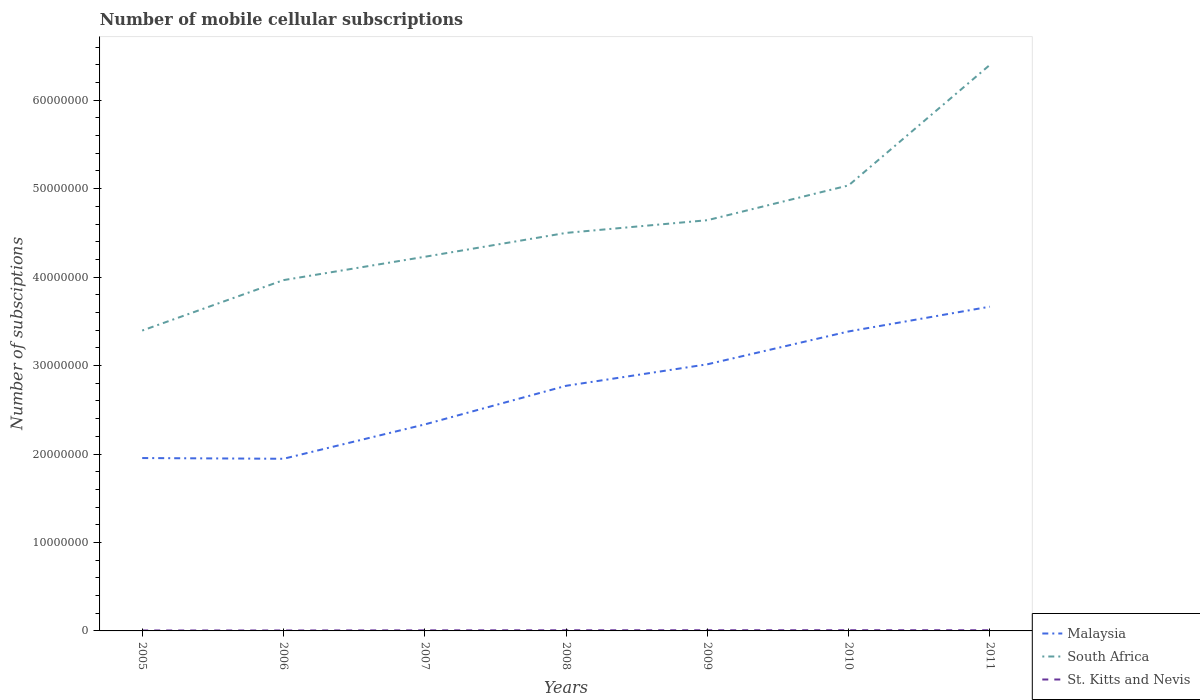Does the line corresponding to South Africa intersect with the line corresponding to St. Kitts and Nevis?
Offer a terse response. No. Is the number of lines equal to the number of legend labels?
Your response must be concise. Yes. Across all years, what is the maximum number of mobile cellular subscriptions in Malaysia?
Your answer should be very brief. 1.95e+07. What is the total number of mobile cellular subscriptions in Malaysia in the graph?
Give a very brief answer. -2.43e+06. What is the difference between the highest and the second highest number of mobile cellular subscriptions in Malaysia?
Your answer should be compact. 1.72e+07. How many lines are there?
Provide a short and direct response. 3. How many years are there in the graph?
Give a very brief answer. 7. Are the values on the major ticks of Y-axis written in scientific E-notation?
Offer a terse response. No. Does the graph contain any zero values?
Your answer should be very brief. No. Does the graph contain grids?
Make the answer very short. No. How many legend labels are there?
Your answer should be very brief. 3. How are the legend labels stacked?
Your answer should be very brief. Vertical. What is the title of the graph?
Give a very brief answer. Number of mobile cellular subscriptions. Does "Vietnam" appear as one of the legend labels in the graph?
Ensure brevity in your answer.  No. What is the label or title of the X-axis?
Offer a very short reply. Years. What is the label or title of the Y-axis?
Your response must be concise. Number of subsciptions. What is the Number of subsciptions in Malaysia in 2005?
Give a very brief answer. 1.95e+07. What is the Number of subsciptions of South Africa in 2005?
Make the answer very short. 3.40e+07. What is the Number of subsciptions in St. Kitts and Nevis in 2005?
Your answer should be compact. 5.10e+04. What is the Number of subsciptions in Malaysia in 2006?
Keep it short and to the point. 1.95e+07. What is the Number of subsciptions in South Africa in 2006?
Make the answer very short. 3.97e+07. What is the Number of subsciptions in St. Kitts and Nevis in 2006?
Your answer should be very brief. 5.10e+04. What is the Number of subsciptions in Malaysia in 2007?
Provide a succinct answer. 2.33e+07. What is the Number of subsciptions of South Africa in 2007?
Make the answer very short. 4.23e+07. What is the Number of subsciptions of St. Kitts and Nevis in 2007?
Offer a terse response. 6.45e+04. What is the Number of subsciptions of Malaysia in 2008?
Your answer should be very brief. 2.77e+07. What is the Number of subsciptions in South Africa in 2008?
Offer a terse response. 4.50e+07. What is the Number of subsciptions in St. Kitts and Nevis in 2008?
Your answer should be compact. 7.45e+04. What is the Number of subsciptions of Malaysia in 2009?
Your answer should be compact. 3.01e+07. What is the Number of subsciptions of South Africa in 2009?
Offer a very short reply. 4.64e+07. What is the Number of subsciptions of St. Kitts and Nevis in 2009?
Provide a succinct answer. 7.55e+04. What is the Number of subsciptions of Malaysia in 2010?
Offer a terse response. 3.39e+07. What is the Number of subsciptions in South Africa in 2010?
Ensure brevity in your answer.  5.04e+07. What is the Number of subsciptions of Malaysia in 2011?
Your answer should be very brief. 3.67e+07. What is the Number of subsciptions in South Africa in 2011?
Provide a succinct answer. 6.40e+07. What is the Number of subsciptions of St. Kitts and Nevis in 2011?
Give a very brief answer. 7.70e+04. Across all years, what is the maximum Number of subsciptions of Malaysia?
Make the answer very short. 3.67e+07. Across all years, what is the maximum Number of subsciptions in South Africa?
Provide a short and direct response. 6.40e+07. Across all years, what is the minimum Number of subsciptions of Malaysia?
Offer a terse response. 1.95e+07. Across all years, what is the minimum Number of subsciptions of South Africa?
Your response must be concise. 3.40e+07. Across all years, what is the minimum Number of subsciptions of St. Kitts and Nevis?
Make the answer very short. 5.10e+04. What is the total Number of subsciptions in Malaysia in the graph?
Offer a very short reply. 1.91e+08. What is the total Number of subsciptions of South Africa in the graph?
Your answer should be compact. 3.22e+08. What is the total Number of subsciptions of St. Kitts and Nevis in the graph?
Keep it short and to the point. 4.74e+05. What is the difference between the Number of subsciptions in Malaysia in 2005 and that in 2006?
Your response must be concise. 8.13e+04. What is the difference between the Number of subsciptions in South Africa in 2005 and that in 2006?
Make the answer very short. -5.70e+06. What is the difference between the Number of subsciptions of St. Kitts and Nevis in 2005 and that in 2006?
Offer a terse response. 0. What is the difference between the Number of subsciptions in Malaysia in 2005 and that in 2007?
Provide a short and direct response. -3.80e+06. What is the difference between the Number of subsciptions of South Africa in 2005 and that in 2007?
Make the answer very short. -8.34e+06. What is the difference between the Number of subsciptions in St. Kitts and Nevis in 2005 and that in 2007?
Your answer should be very brief. -1.35e+04. What is the difference between the Number of subsciptions of Malaysia in 2005 and that in 2008?
Provide a succinct answer. -8.17e+06. What is the difference between the Number of subsciptions in South Africa in 2005 and that in 2008?
Your answer should be compact. -1.10e+07. What is the difference between the Number of subsciptions in St. Kitts and Nevis in 2005 and that in 2008?
Provide a short and direct response. -2.35e+04. What is the difference between the Number of subsciptions of Malaysia in 2005 and that in 2009?
Provide a short and direct response. -1.06e+07. What is the difference between the Number of subsciptions of South Africa in 2005 and that in 2009?
Make the answer very short. -1.25e+07. What is the difference between the Number of subsciptions in St. Kitts and Nevis in 2005 and that in 2009?
Give a very brief answer. -2.45e+04. What is the difference between the Number of subsciptions in Malaysia in 2005 and that in 2010?
Your response must be concise. -1.43e+07. What is the difference between the Number of subsciptions in South Africa in 2005 and that in 2010?
Provide a short and direct response. -1.64e+07. What is the difference between the Number of subsciptions in St. Kitts and Nevis in 2005 and that in 2010?
Make the answer very short. -2.90e+04. What is the difference between the Number of subsciptions of Malaysia in 2005 and that in 2011?
Give a very brief answer. -1.71e+07. What is the difference between the Number of subsciptions of South Africa in 2005 and that in 2011?
Your answer should be very brief. -3.00e+07. What is the difference between the Number of subsciptions in St. Kitts and Nevis in 2005 and that in 2011?
Provide a short and direct response. -2.60e+04. What is the difference between the Number of subsciptions in Malaysia in 2006 and that in 2007?
Your answer should be very brief. -3.88e+06. What is the difference between the Number of subsciptions of South Africa in 2006 and that in 2007?
Your answer should be compact. -2.64e+06. What is the difference between the Number of subsciptions in St. Kitts and Nevis in 2006 and that in 2007?
Give a very brief answer. -1.35e+04. What is the difference between the Number of subsciptions of Malaysia in 2006 and that in 2008?
Give a very brief answer. -8.25e+06. What is the difference between the Number of subsciptions in South Africa in 2006 and that in 2008?
Your response must be concise. -5.34e+06. What is the difference between the Number of subsciptions of St. Kitts and Nevis in 2006 and that in 2008?
Give a very brief answer. -2.35e+04. What is the difference between the Number of subsciptions in Malaysia in 2006 and that in 2009?
Your answer should be compact. -1.07e+07. What is the difference between the Number of subsciptions of South Africa in 2006 and that in 2009?
Provide a short and direct response. -6.77e+06. What is the difference between the Number of subsciptions in St. Kitts and Nevis in 2006 and that in 2009?
Offer a terse response. -2.45e+04. What is the difference between the Number of subsciptions in Malaysia in 2006 and that in 2010?
Your response must be concise. -1.44e+07. What is the difference between the Number of subsciptions in South Africa in 2006 and that in 2010?
Your response must be concise. -1.07e+07. What is the difference between the Number of subsciptions in St. Kitts and Nevis in 2006 and that in 2010?
Make the answer very short. -2.90e+04. What is the difference between the Number of subsciptions of Malaysia in 2006 and that in 2011?
Your answer should be compact. -1.72e+07. What is the difference between the Number of subsciptions in South Africa in 2006 and that in 2011?
Provide a short and direct response. -2.43e+07. What is the difference between the Number of subsciptions of St. Kitts and Nevis in 2006 and that in 2011?
Your answer should be very brief. -2.60e+04. What is the difference between the Number of subsciptions in Malaysia in 2007 and that in 2008?
Keep it short and to the point. -4.37e+06. What is the difference between the Number of subsciptions in South Africa in 2007 and that in 2008?
Your answer should be very brief. -2.70e+06. What is the difference between the Number of subsciptions in St. Kitts and Nevis in 2007 and that in 2008?
Give a very brief answer. -10000. What is the difference between the Number of subsciptions of Malaysia in 2007 and that in 2009?
Make the answer very short. -6.80e+06. What is the difference between the Number of subsciptions in South Africa in 2007 and that in 2009?
Provide a short and direct response. -4.14e+06. What is the difference between the Number of subsciptions of St. Kitts and Nevis in 2007 and that in 2009?
Offer a very short reply. -1.10e+04. What is the difference between the Number of subsciptions of Malaysia in 2007 and that in 2010?
Provide a short and direct response. -1.05e+07. What is the difference between the Number of subsciptions in South Africa in 2007 and that in 2010?
Offer a very short reply. -8.07e+06. What is the difference between the Number of subsciptions of St. Kitts and Nevis in 2007 and that in 2010?
Offer a terse response. -1.55e+04. What is the difference between the Number of subsciptions of Malaysia in 2007 and that in 2011?
Keep it short and to the point. -1.33e+07. What is the difference between the Number of subsciptions of South Africa in 2007 and that in 2011?
Your answer should be very brief. -2.17e+07. What is the difference between the Number of subsciptions of St. Kitts and Nevis in 2007 and that in 2011?
Offer a very short reply. -1.25e+04. What is the difference between the Number of subsciptions of Malaysia in 2008 and that in 2009?
Offer a very short reply. -2.43e+06. What is the difference between the Number of subsciptions in South Africa in 2008 and that in 2009?
Offer a terse response. -1.44e+06. What is the difference between the Number of subsciptions of St. Kitts and Nevis in 2008 and that in 2009?
Ensure brevity in your answer.  -1000. What is the difference between the Number of subsciptions of Malaysia in 2008 and that in 2010?
Offer a very short reply. -6.15e+06. What is the difference between the Number of subsciptions in South Africa in 2008 and that in 2010?
Provide a succinct answer. -5.37e+06. What is the difference between the Number of subsciptions of St. Kitts and Nevis in 2008 and that in 2010?
Offer a very short reply. -5500. What is the difference between the Number of subsciptions in Malaysia in 2008 and that in 2011?
Your answer should be compact. -8.95e+06. What is the difference between the Number of subsciptions in South Africa in 2008 and that in 2011?
Ensure brevity in your answer.  -1.90e+07. What is the difference between the Number of subsciptions in St. Kitts and Nevis in 2008 and that in 2011?
Provide a short and direct response. -2500. What is the difference between the Number of subsciptions in Malaysia in 2009 and that in 2010?
Provide a short and direct response. -3.71e+06. What is the difference between the Number of subsciptions of South Africa in 2009 and that in 2010?
Offer a very short reply. -3.94e+06. What is the difference between the Number of subsciptions in St. Kitts and Nevis in 2009 and that in 2010?
Offer a terse response. -4500. What is the difference between the Number of subsciptions of Malaysia in 2009 and that in 2011?
Your answer should be compact. -6.52e+06. What is the difference between the Number of subsciptions of South Africa in 2009 and that in 2011?
Your response must be concise. -1.76e+07. What is the difference between the Number of subsciptions in St. Kitts and Nevis in 2009 and that in 2011?
Your response must be concise. -1500. What is the difference between the Number of subsciptions of Malaysia in 2010 and that in 2011?
Offer a terse response. -2.80e+06. What is the difference between the Number of subsciptions of South Africa in 2010 and that in 2011?
Provide a succinct answer. -1.36e+07. What is the difference between the Number of subsciptions of St. Kitts and Nevis in 2010 and that in 2011?
Offer a terse response. 3000. What is the difference between the Number of subsciptions of Malaysia in 2005 and the Number of subsciptions of South Africa in 2006?
Keep it short and to the point. -2.01e+07. What is the difference between the Number of subsciptions in Malaysia in 2005 and the Number of subsciptions in St. Kitts and Nevis in 2006?
Ensure brevity in your answer.  1.95e+07. What is the difference between the Number of subsciptions in South Africa in 2005 and the Number of subsciptions in St. Kitts and Nevis in 2006?
Your answer should be very brief. 3.39e+07. What is the difference between the Number of subsciptions in Malaysia in 2005 and the Number of subsciptions in South Africa in 2007?
Your response must be concise. -2.28e+07. What is the difference between the Number of subsciptions of Malaysia in 2005 and the Number of subsciptions of St. Kitts and Nevis in 2007?
Offer a terse response. 1.95e+07. What is the difference between the Number of subsciptions in South Africa in 2005 and the Number of subsciptions in St. Kitts and Nevis in 2007?
Offer a terse response. 3.39e+07. What is the difference between the Number of subsciptions in Malaysia in 2005 and the Number of subsciptions in South Africa in 2008?
Offer a very short reply. -2.55e+07. What is the difference between the Number of subsciptions of Malaysia in 2005 and the Number of subsciptions of St. Kitts and Nevis in 2008?
Keep it short and to the point. 1.95e+07. What is the difference between the Number of subsciptions of South Africa in 2005 and the Number of subsciptions of St. Kitts and Nevis in 2008?
Your answer should be compact. 3.39e+07. What is the difference between the Number of subsciptions in Malaysia in 2005 and the Number of subsciptions in South Africa in 2009?
Provide a short and direct response. -2.69e+07. What is the difference between the Number of subsciptions in Malaysia in 2005 and the Number of subsciptions in St. Kitts and Nevis in 2009?
Ensure brevity in your answer.  1.95e+07. What is the difference between the Number of subsciptions in South Africa in 2005 and the Number of subsciptions in St. Kitts and Nevis in 2009?
Keep it short and to the point. 3.39e+07. What is the difference between the Number of subsciptions in Malaysia in 2005 and the Number of subsciptions in South Africa in 2010?
Your response must be concise. -3.08e+07. What is the difference between the Number of subsciptions of Malaysia in 2005 and the Number of subsciptions of St. Kitts and Nevis in 2010?
Provide a short and direct response. 1.95e+07. What is the difference between the Number of subsciptions in South Africa in 2005 and the Number of subsciptions in St. Kitts and Nevis in 2010?
Your answer should be very brief. 3.39e+07. What is the difference between the Number of subsciptions in Malaysia in 2005 and the Number of subsciptions in South Africa in 2011?
Offer a terse response. -4.45e+07. What is the difference between the Number of subsciptions in Malaysia in 2005 and the Number of subsciptions in St. Kitts and Nevis in 2011?
Keep it short and to the point. 1.95e+07. What is the difference between the Number of subsciptions in South Africa in 2005 and the Number of subsciptions in St. Kitts and Nevis in 2011?
Provide a succinct answer. 3.39e+07. What is the difference between the Number of subsciptions in Malaysia in 2006 and the Number of subsciptions in South Africa in 2007?
Your answer should be compact. -2.28e+07. What is the difference between the Number of subsciptions in Malaysia in 2006 and the Number of subsciptions in St. Kitts and Nevis in 2007?
Your answer should be compact. 1.94e+07. What is the difference between the Number of subsciptions in South Africa in 2006 and the Number of subsciptions in St. Kitts and Nevis in 2007?
Offer a terse response. 3.96e+07. What is the difference between the Number of subsciptions in Malaysia in 2006 and the Number of subsciptions in South Africa in 2008?
Make the answer very short. -2.55e+07. What is the difference between the Number of subsciptions of Malaysia in 2006 and the Number of subsciptions of St. Kitts and Nevis in 2008?
Offer a very short reply. 1.94e+07. What is the difference between the Number of subsciptions of South Africa in 2006 and the Number of subsciptions of St. Kitts and Nevis in 2008?
Your answer should be compact. 3.96e+07. What is the difference between the Number of subsciptions of Malaysia in 2006 and the Number of subsciptions of South Africa in 2009?
Offer a very short reply. -2.70e+07. What is the difference between the Number of subsciptions of Malaysia in 2006 and the Number of subsciptions of St. Kitts and Nevis in 2009?
Your answer should be very brief. 1.94e+07. What is the difference between the Number of subsciptions in South Africa in 2006 and the Number of subsciptions in St. Kitts and Nevis in 2009?
Your answer should be very brief. 3.96e+07. What is the difference between the Number of subsciptions of Malaysia in 2006 and the Number of subsciptions of South Africa in 2010?
Offer a very short reply. -3.09e+07. What is the difference between the Number of subsciptions of Malaysia in 2006 and the Number of subsciptions of St. Kitts and Nevis in 2010?
Provide a short and direct response. 1.94e+07. What is the difference between the Number of subsciptions of South Africa in 2006 and the Number of subsciptions of St. Kitts and Nevis in 2010?
Provide a succinct answer. 3.96e+07. What is the difference between the Number of subsciptions of Malaysia in 2006 and the Number of subsciptions of South Africa in 2011?
Give a very brief answer. -4.45e+07. What is the difference between the Number of subsciptions in Malaysia in 2006 and the Number of subsciptions in St. Kitts and Nevis in 2011?
Keep it short and to the point. 1.94e+07. What is the difference between the Number of subsciptions in South Africa in 2006 and the Number of subsciptions in St. Kitts and Nevis in 2011?
Your answer should be very brief. 3.96e+07. What is the difference between the Number of subsciptions in Malaysia in 2007 and the Number of subsciptions in South Africa in 2008?
Ensure brevity in your answer.  -2.17e+07. What is the difference between the Number of subsciptions of Malaysia in 2007 and the Number of subsciptions of St. Kitts and Nevis in 2008?
Provide a short and direct response. 2.33e+07. What is the difference between the Number of subsciptions in South Africa in 2007 and the Number of subsciptions in St. Kitts and Nevis in 2008?
Offer a very short reply. 4.22e+07. What is the difference between the Number of subsciptions in Malaysia in 2007 and the Number of subsciptions in South Africa in 2009?
Ensure brevity in your answer.  -2.31e+07. What is the difference between the Number of subsciptions in Malaysia in 2007 and the Number of subsciptions in St. Kitts and Nevis in 2009?
Make the answer very short. 2.33e+07. What is the difference between the Number of subsciptions in South Africa in 2007 and the Number of subsciptions in St. Kitts and Nevis in 2009?
Give a very brief answer. 4.22e+07. What is the difference between the Number of subsciptions of Malaysia in 2007 and the Number of subsciptions of South Africa in 2010?
Provide a succinct answer. -2.70e+07. What is the difference between the Number of subsciptions in Malaysia in 2007 and the Number of subsciptions in St. Kitts and Nevis in 2010?
Offer a very short reply. 2.33e+07. What is the difference between the Number of subsciptions in South Africa in 2007 and the Number of subsciptions in St. Kitts and Nevis in 2010?
Provide a short and direct response. 4.22e+07. What is the difference between the Number of subsciptions in Malaysia in 2007 and the Number of subsciptions in South Africa in 2011?
Offer a very short reply. -4.07e+07. What is the difference between the Number of subsciptions in Malaysia in 2007 and the Number of subsciptions in St. Kitts and Nevis in 2011?
Keep it short and to the point. 2.33e+07. What is the difference between the Number of subsciptions in South Africa in 2007 and the Number of subsciptions in St. Kitts and Nevis in 2011?
Your answer should be compact. 4.22e+07. What is the difference between the Number of subsciptions in Malaysia in 2008 and the Number of subsciptions in South Africa in 2009?
Provide a short and direct response. -1.87e+07. What is the difference between the Number of subsciptions in Malaysia in 2008 and the Number of subsciptions in St. Kitts and Nevis in 2009?
Offer a terse response. 2.76e+07. What is the difference between the Number of subsciptions of South Africa in 2008 and the Number of subsciptions of St. Kitts and Nevis in 2009?
Provide a short and direct response. 4.49e+07. What is the difference between the Number of subsciptions in Malaysia in 2008 and the Number of subsciptions in South Africa in 2010?
Offer a very short reply. -2.27e+07. What is the difference between the Number of subsciptions of Malaysia in 2008 and the Number of subsciptions of St. Kitts and Nevis in 2010?
Provide a succinct answer. 2.76e+07. What is the difference between the Number of subsciptions of South Africa in 2008 and the Number of subsciptions of St. Kitts and Nevis in 2010?
Give a very brief answer. 4.49e+07. What is the difference between the Number of subsciptions in Malaysia in 2008 and the Number of subsciptions in South Africa in 2011?
Provide a succinct answer. -3.63e+07. What is the difference between the Number of subsciptions of Malaysia in 2008 and the Number of subsciptions of St. Kitts and Nevis in 2011?
Provide a short and direct response. 2.76e+07. What is the difference between the Number of subsciptions in South Africa in 2008 and the Number of subsciptions in St. Kitts and Nevis in 2011?
Provide a short and direct response. 4.49e+07. What is the difference between the Number of subsciptions in Malaysia in 2009 and the Number of subsciptions in South Africa in 2010?
Offer a very short reply. -2.02e+07. What is the difference between the Number of subsciptions in Malaysia in 2009 and the Number of subsciptions in St. Kitts and Nevis in 2010?
Your answer should be compact. 3.01e+07. What is the difference between the Number of subsciptions of South Africa in 2009 and the Number of subsciptions of St. Kitts and Nevis in 2010?
Keep it short and to the point. 4.64e+07. What is the difference between the Number of subsciptions in Malaysia in 2009 and the Number of subsciptions in South Africa in 2011?
Give a very brief answer. -3.39e+07. What is the difference between the Number of subsciptions in Malaysia in 2009 and the Number of subsciptions in St. Kitts and Nevis in 2011?
Offer a very short reply. 3.01e+07. What is the difference between the Number of subsciptions in South Africa in 2009 and the Number of subsciptions in St. Kitts and Nevis in 2011?
Your answer should be compact. 4.64e+07. What is the difference between the Number of subsciptions of Malaysia in 2010 and the Number of subsciptions of South Africa in 2011?
Your response must be concise. -3.01e+07. What is the difference between the Number of subsciptions of Malaysia in 2010 and the Number of subsciptions of St. Kitts and Nevis in 2011?
Your answer should be very brief. 3.38e+07. What is the difference between the Number of subsciptions in South Africa in 2010 and the Number of subsciptions in St. Kitts and Nevis in 2011?
Make the answer very short. 5.03e+07. What is the average Number of subsciptions in Malaysia per year?
Offer a very short reply. 2.72e+07. What is the average Number of subsciptions of South Africa per year?
Give a very brief answer. 4.60e+07. What is the average Number of subsciptions of St. Kitts and Nevis per year?
Offer a terse response. 6.76e+04. In the year 2005, what is the difference between the Number of subsciptions in Malaysia and Number of subsciptions in South Africa?
Provide a short and direct response. -1.44e+07. In the year 2005, what is the difference between the Number of subsciptions in Malaysia and Number of subsciptions in St. Kitts and Nevis?
Provide a succinct answer. 1.95e+07. In the year 2005, what is the difference between the Number of subsciptions of South Africa and Number of subsciptions of St. Kitts and Nevis?
Offer a very short reply. 3.39e+07. In the year 2006, what is the difference between the Number of subsciptions of Malaysia and Number of subsciptions of South Africa?
Offer a terse response. -2.02e+07. In the year 2006, what is the difference between the Number of subsciptions of Malaysia and Number of subsciptions of St. Kitts and Nevis?
Offer a terse response. 1.94e+07. In the year 2006, what is the difference between the Number of subsciptions of South Africa and Number of subsciptions of St. Kitts and Nevis?
Offer a very short reply. 3.96e+07. In the year 2007, what is the difference between the Number of subsciptions in Malaysia and Number of subsciptions in South Africa?
Give a very brief answer. -1.90e+07. In the year 2007, what is the difference between the Number of subsciptions of Malaysia and Number of subsciptions of St. Kitts and Nevis?
Offer a very short reply. 2.33e+07. In the year 2007, what is the difference between the Number of subsciptions in South Africa and Number of subsciptions in St. Kitts and Nevis?
Your answer should be very brief. 4.22e+07. In the year 2008, what is the difference between the Number of subsciptions in Malaysia and Number of subsciptions in South Africa?
Offer a very short reply. -1.73e+07. In the year 2008, what is the difference between the Number of subsciptions in Malaysia and Number of subsciptions in St. Kitts and Nevis?
Offer a terse response. 2.76e+07. In the year 2008, what is the difference between the Number of subsciptions in South Africa and Number of subsciptions in St. Kitts and Nevis?
Provide a short and direct response. 4.49e+07. In the year 2009, what is the difference between the Number of subsciptions in Malaysia and Number of subsciptions in South Africa?
Keep it short and to the point. -1.63e+07. In the year 2009, what is the difference between the Number of subsciptions of Malaysia and Number of subsciptions of St. Kitts and Nevis?
Your response must be concise. 3.01e+07. In the year 2009, what is the difference between the Number of subsciptions in South Africa and Number of subsciptions in St. Kitts and Nevis?
Your answer should be compact. 4.64e+07. In the year 2010, what is the difference between the Number of subsciptions in Malaysia and Number of subsciptions in South Africa?
Offer a terse response. -1.65e+07. In the year 2010, what is the difference between the Number of subsciptions in Malaysia and Number of subsciptions in St. Kitts and Nevis?
Your response must be concise. 3.38e+07. In the year 2010, what is the difference between the Number of subsciptions of South Africa and Number of subsciptions of St. Kitts and Nevis?
Your answer should be very brief. 5.03e+07. In the year 2011, what is the difference between the Number of subsciptions in Malaysia and Number of subsciptions in South Africa?
Offer a terse response. -2.73e+07. In the year 2011, what is the difference between the Number of subsciptions of Malaysia and Number of subsciptions of St. Kitts and Nevis?
Offer a terse response. 3.66e+07. In the year 2011, what is the difference between the Number of subsciptions of South Africa and Number of subsciptions of St. Kitts and Nevis?
Ensure brevity in your answer.  6.39e+07. What is the ratio of the Number of subsciptions in South Africa in 2005 to that in 2006?
Provide a short and direct response. 0.86. What is the ratio of the Number of subsciptions of St. Kitts and Nevis in 2005 to that in 2006?
Provide a succinct answer. 1. What is the ratio of the Number of subsciptions in Malaysia in 2005 to that in 2007?
Provide a short and direct response. 0.84. What is the ratio of the Number of subsciptions in South Africa in 2005 to that in 2007?
Your response must be concise. 0.8. What is the ratio of the Number of subsciptions of St. Kitts and Nevis in 2005 to that in 2007?
Offer a very short reply. 0.79. What is the ratio of the Number of subsciptions in Malaysia in 2005 to that in 2008?
Provide a succinct answer. 0.71. What is the ratio of the Number of subsciptions in South Africa in 2005 to that in 2008?
Offer a terse response. 0.75. What is the ratio of the Number of subsciptions in St. Kitts and Nevis in 2005 to that in 2008?
Offer a very short reply. 0.68. What is the ratio of the Number of subsciptions of Malaysia in 2005 to that in 2009?
Offer a terse response. 0.65. What is the ratio of the Number of subsciptions in South Africa in 2005 to that in 2009?
Make the answer very short. 0.73. What is the ratio of the Number of subsciptions in St. Kitts and Nevis in 2005 to that in 2009?
Offer a terse response. 0.68. What is the ratio of the Number of subsciptions of Malaysia in 2005 to that in 2010?
Offer a very short reply. 0.58. What is the ratio of the Number of subsciptions of South Africa in 2005 to that in 2010?
Offer a terse response. 0.67. What is the ratio of the Number of subsciptions in St. Kitts and Nevis in 2005 to that in 2010?
Keep it short and to the point. 0.64. What is the ratio of the Number of subsciptions in Malaysia in 2005 to that in 2011?
Offer a very short reply. 0.53. What is the ratio of the Number of subsciptions in South Africa in 2005 to that in 2011?
Offer a terse response. 0.53. What is the ratio of the Number of subsciptions of St. Kitts and Nevis in 2005 to that in 2011?
Your response must be concise. 0.66. What is the ratio of the Number of subsciptions of Malaysia in 2006 to that in 2007?
Ensure brevity in your answer.  0.83. What is the ratio of the Number of subsciptions of South Africa in 2006 to that in 2007?
Provide a succinct answer. 0.94. What is the ratio of the Number of subsciptions in St. Kitts and Nevis in 2006 to that in 2007?
Offer a terse response. 0.79. What is the ratio of the Number of subsciptions in Malaysia in 2006 to that in 2008?
Provide a short and direct response. 0.7. What is the ratio of the Number of subsciptions in South Africa in 2006 to that in 2008?
Your answer should be compact. 0.88. What is the ratio of the Number of subsciptions in St. Kitts and Nevis in 2006 to that in 2008?
Provide a short and direct response. 0.68. What is the ratio of the Number of subsciptions of Malaysia in 2006 to that in 2009?
Offer a terse response. 0.65. What is the ratio of the Number of subsciptions of South Africa in 2006 to that in 2009?
Your answer should be compact. 0.85. What is the ratio of the Number of subsciptions in St. Kitts and Nevis in 2006 to that in 2009?
Provide a short and direct response. 0.68. What is the ratio of the Number of subsciptions in Malaysia in 2006 to that in 2010?
Keep it short and to the point. 0.57. What is the ratio of the Number of subsciptions in South Africa in 2006 to that in 2010?
Make the answer very short. 0.79. What is the ratio of the Number of subsciptions of St. Kitts and Nevis in 2006 to that in 2010?
Offer a very short reply. 0.64. What is the ratio of the Number of subsciptions in Malaysia in 2006 to that in 2011?
Ensure brevity in your answer.  0.53. What is the ratio of the Number of subsciptions in South Africa in 2006 to that in 2011?
Your answer should be compact. 0.62. What is the ratio of the Number of subsciptions of St. Kitts and Nevis in 2006 to that in 2011?
Your answer should be compact. 0.66. What is the ratio of the Number of subsciptions of Malaysia in 2007 to that in 2008?
Ensure brevity in your answer.  0.84. What is the ratio of the Number of subsciptions of St. Kitts and Nevis in 2007 to that in 2008?
Make the answer very short. 0.87. What is the ratio of the Number of subsciptions of Malaysia in 2007 to that in 2009?
Provide a succinct answer. 0.77. What is the ratio of the Number of subsciptions in South Africa in 2007 to that in 2009?
Offer a very short reply. 0.91. What is the ratio of the Number of subsciptions in St. Kitts and Nevis in 2007 to that in 2009?
Provide a short and direct response. 0.85. What is the ratio of the Number of subsciptions of Malaysia in 2007 to that in 2010?
Your answer should be compact. 0.69. What is the ratio of the Number of subsciptions in South Africa in 2007 to that in 2010?
Provide a succinct answer. 0.84. What is the ratio of the Number of subsciptions of St. Kitts and Nevis in 2007 to that in 2010?
Your answer should be compact. 0.81. What is the ratio of the Number of subsciptions of Malaysia in 2007 to that in 2011?
Provide a succinct answer. 0.64. What is the ratio of the Number of subsciptions of South Africa in 2007 to that in 2011?
Provide a succinct answer. 0.66. What is the ratio of the Number of subsciptions of St. Kitts and Nevis in 2007 to that in 2011?
Your response must be concise. 0.84. What is the ratio of the Number of subsciptions in Malaysia in 2008 to that in 2009?
Ensure brevity in your answer.  0.92. What is the ratio of the Number of subsciptions in South Africa in 2008 to that in 2009?
Your answer should be compact. 0.97. What is the ratio of the Number of subsciptions of St. Kitts and Nevis in 2008 to that in 2009?
Your response must be concise. 0.99. What is the ratio of the Number of subsciptions in Malaysia in 2008 to that in 2010?
Ensure brevity in your answer.  0.82. What is the ratio of the Number of subsciptions in South Africa in 2008 to that in 2010?
Provide a short and direct response. 0.89. What is the ratio of the Number of subsciptions in St. Kitts and Nevis in 2008 to that in 2010?
Your response must be concise. 0.93. What is the ratio of the Number of subsciptions in Malaysia in 2008 to that in 2011?
Your response must be concise. 0.76. What is the ratio of the Number of subsciptions in South Africa in 2008 to that in 2011?
Offer a terse response. 0.7. What is the ratio of the Number of subsciptions in St. Kitts and Nevis in 2008 to that in 2011?
Offer a terse response. 0.97. What is the ratio of the Number of subsciptions of Malaysia in 2009 to that in 2010?
Keep it short and to the point. 0.89. What is the ratio of the Number of subsciptions in South Africa in 2009 to that in 2010?
Offer a very short reply. 0.92. What is the ratio of the Number of subsciptions in St. Kitts and Nevis in 2009 to that in 2010?
Offer a very short reply. 0.94. What is the ratio of the Number of subsciptions in Malaysia in 2009 to that in 2011?
Your answer should be very brief. 0.82. What is the ratio of the Number of subsciptions of South Africa in 2009 to that in 2011?
Give a very brief answer. 0.73. What is the ratio of the Number of subsciptions in St. Kitts and Nevis in 2009 to that in 2011?
Give a very brief answer. 0.98. What is the ratio of the Number of subsciptions in Malaysia in 2010 to that in 2011?
Keep it short and to the point. 0.92. What is the ratio of the Number of subsciptions in South Africa in 2010 to that in 2011?
Offer a terse response. 0.79. What is the ratio of the Number of subsciptions of St. Kitts and Nevis in 2010 to that in 2011?
Your response must be concise. 1.04. What is the difference between the highest and the second highest Number of subsciptions in Malaysia?
Your response must be concise. 2.80e+06. What is the difference between the highest and the second highest Number of subsciptions in South Africa?
Your answer should be very brief. 1.36e+07. What is the difference between the highest and the second highest Number of subsciptions in St. Kitts and Nevis?
Make the answer very short. 3000. What is the difference between the highest and the lowest Number of subsciptions of Malaysia?
Your answer should be very brief. 1.72e+07. What is the difference between the highest and the lowest Number of subsciptions of South Africa?
Offer a terse response. 3.00e+07. What is the difference between the highest and the lowest Number of subsciptions in St. Kitts and Nevis?
Keep it short and to the point. 2.90e+04. 